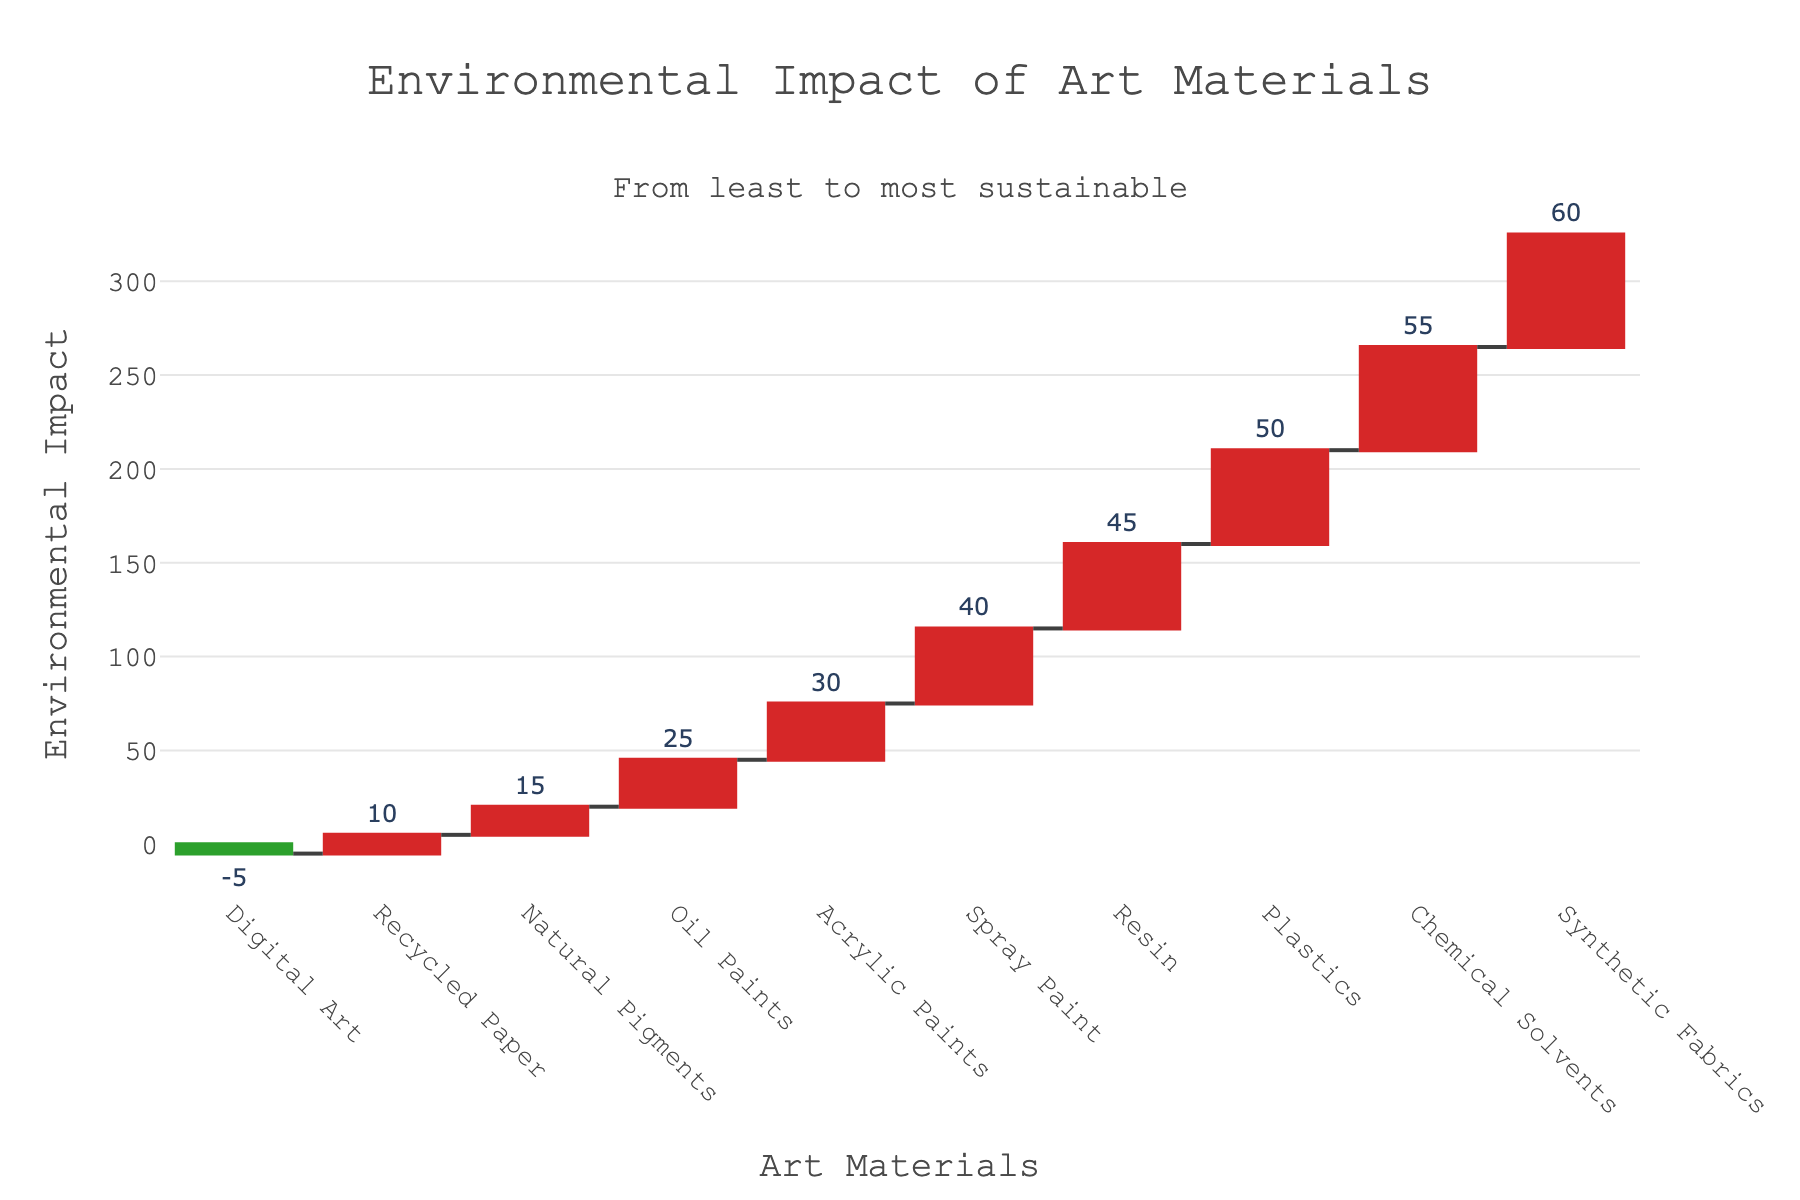What's the title of the plot? The title is usually located at the top of the plot. This one reads "Environmental Impact of Art Materials".
Answer: Environmental Impact of Art Materials Which art material has the highest environmental impact? The highest environmental impact material is identified as the last one in the ascending sorted list with the highest y-value. Here it is "Synthetic Fabrics" with an impact value of 60.
Answer: Synthetic Fabrics How many art materials are represented in the chart? Count the number of different bars/entries in the x-axis to find the total number of art materials illustrated. There are 10 bars/entries.
Answer: 10 What is the environmental impact difference between the least and most sustainable material? The least sustainable material is “Synthetic Fabrics” with an impact of 60, and the most sustainable is “Digital Art” with an impact of -5. Calculate the difference: 60 - (-5) = 65.
Answer: 65 Which colors represent increasing and decreasing impacts? The colors are meant to differentiate between increasing and decreasing impacts in the waterfall chart. Red denotes increasing impacts, while green denotes decreasing impacts.
Answer: Red and Green What is the cumulative environmental impact at "Oil Paints"? To calculate the cumulative impact at "Oil Paints," sum the impacts of all previous materials and include "Oil Paints": 10 (Recycled Paper) - 5 (Digital Art) + 15 (Natural Pigments) + 25 (Oil Paints) = 45.
Answer: 45 Between "Recycled Paper" and "Acrylic Paints", which has a lower environmental impact? Compare the y-values of "Recycled Paper" (10) and "Acrylic Paints" (30). "Recycled Paper" has a lower impact.
Answer: Recycled Paper What is the environmental impact value of "Digital Art"? Locate "Digital Art" on the x-axis and refer to the corresponding y-value. The value is -5.
Answer: -5 Which material is placed at the midpoint when sorted by impact? With 10 materials, the midpoint after sorting is the 5th and 6th materials. “Oil Paints” (25) and “Acrylic Paints” (30) fall in the middle when sorted by impact.
Answer: Oil Paints and Acrylic Paints What annotation is included in the chart, and where is it located? The annotation notes "From least to most sustainable" and is placed slightly above the x-axis, central along the width of the chart.
Answer: From least to most sustainable 